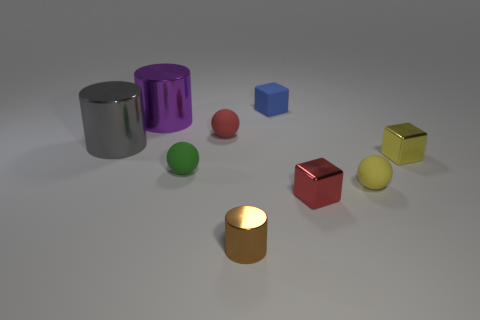Subtract all cylinders. How many objects are left? 6 Add 8 cyan metal balls. How many cyan metal balls exist? 8 Subtract 0 green cylinders. How many objects are left? 9 Subtract all balls. Subtract all large gray cylinders. How many objects are left? 5 Add 9 yellow rubber things. How many yellow rubber things are left? 10 